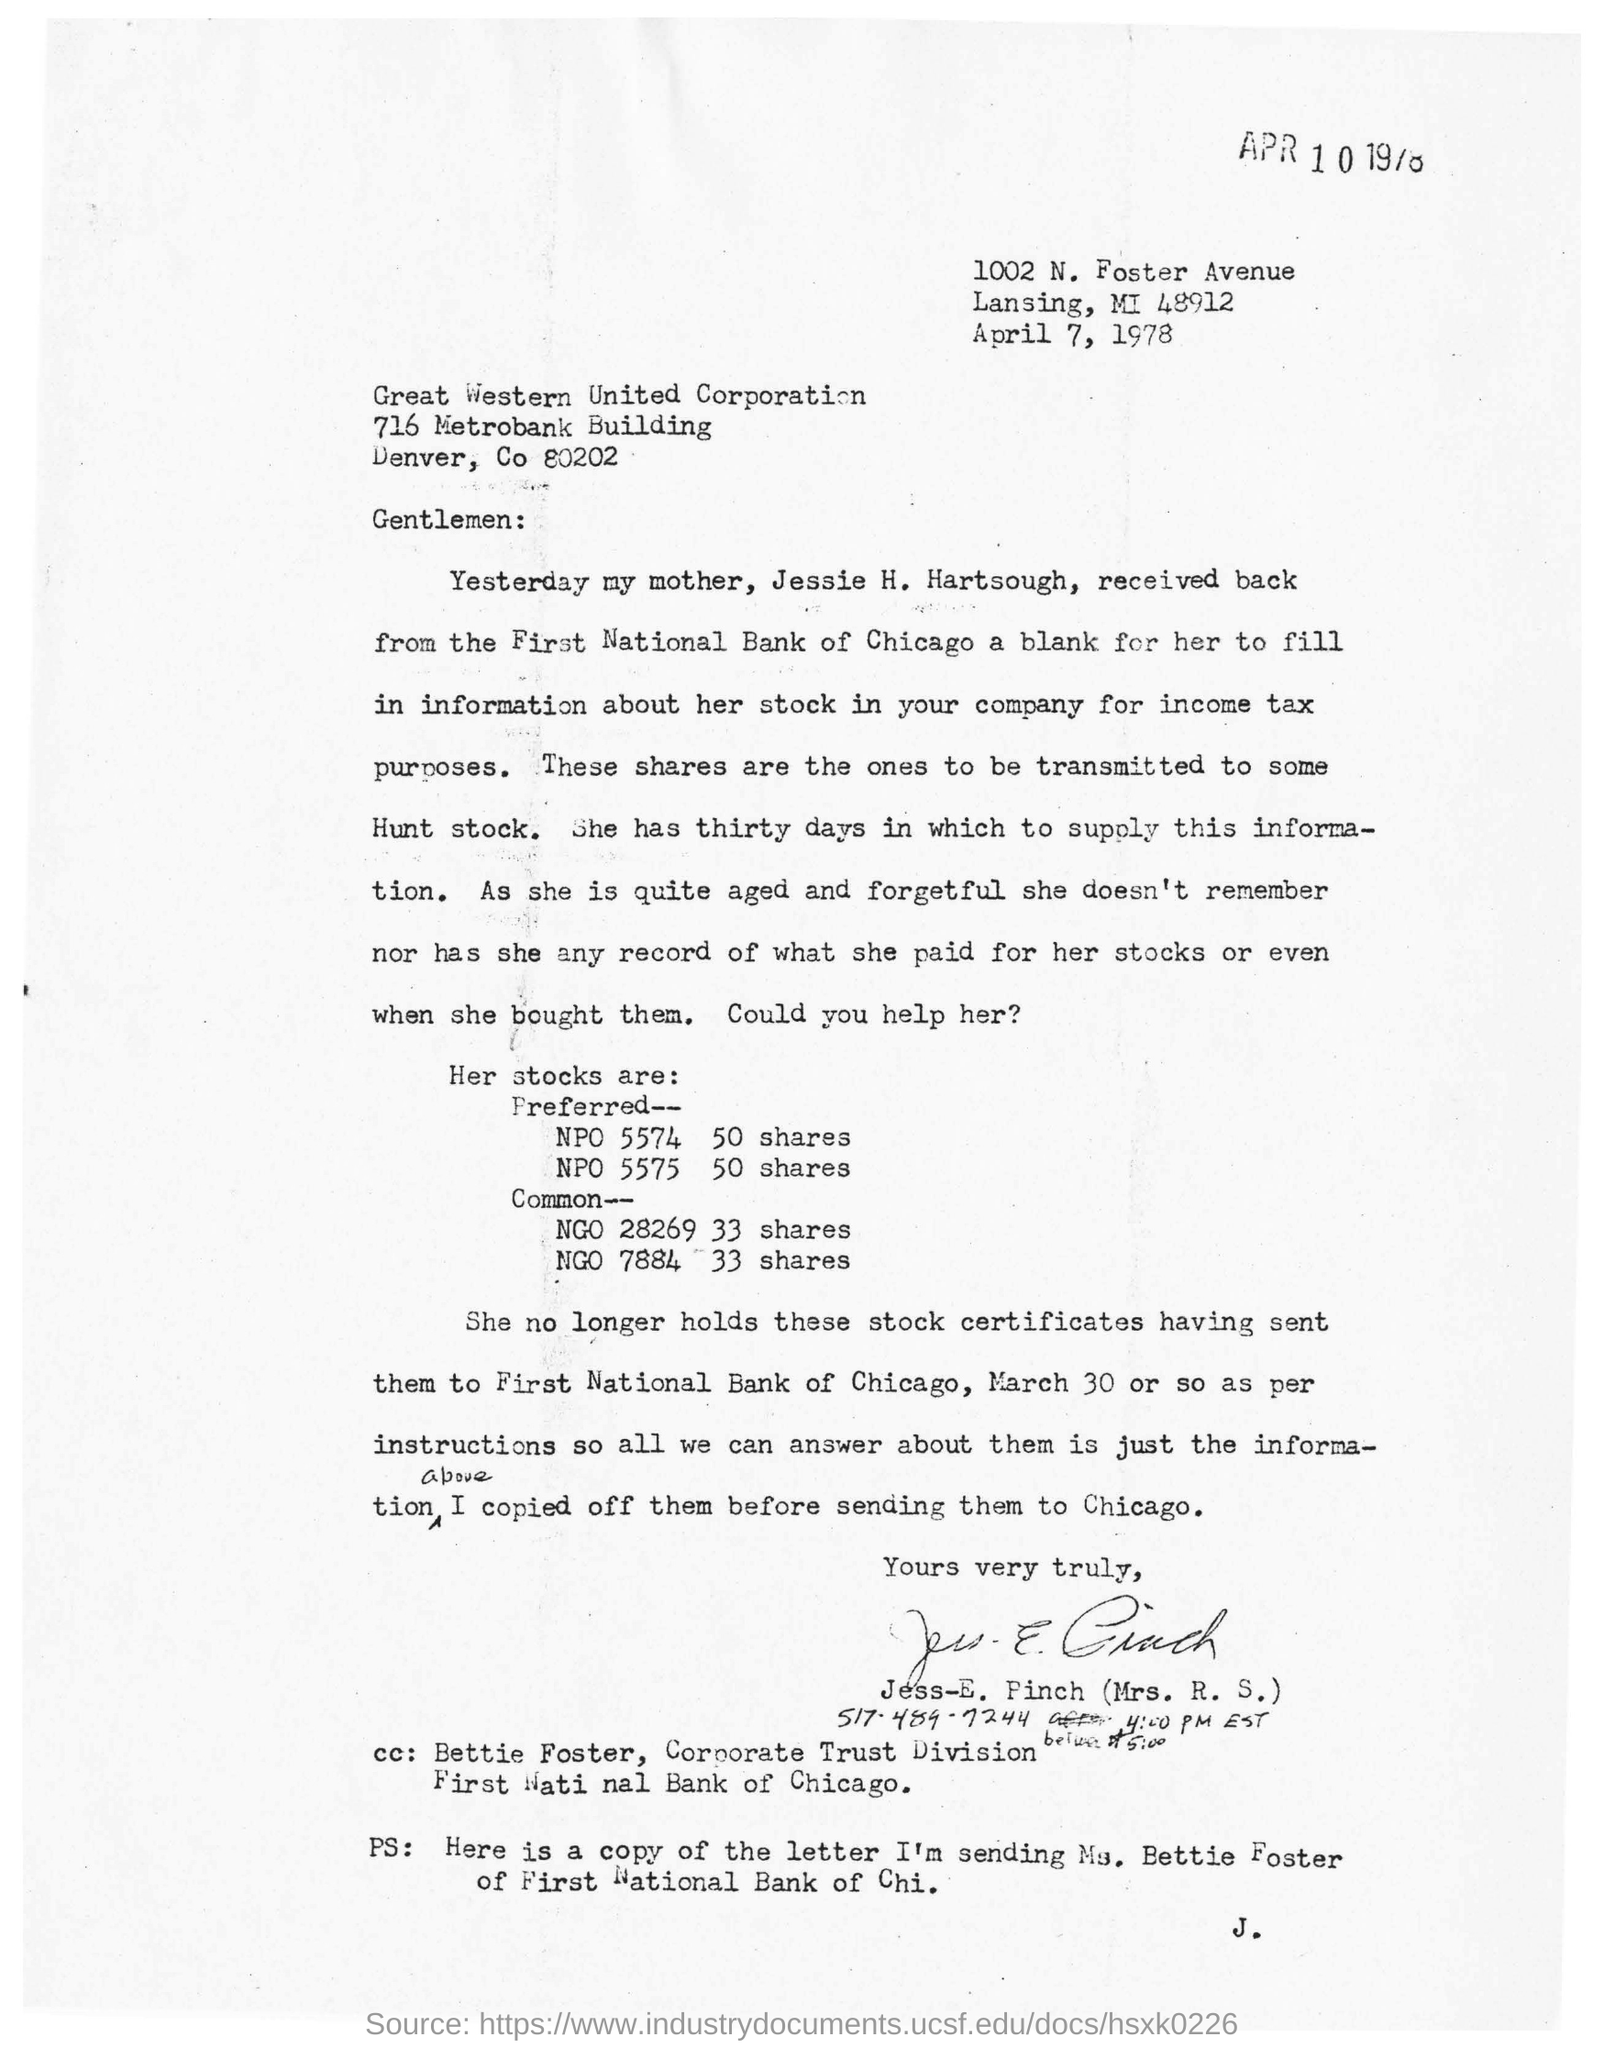When is the letter dated on?
Provide a succinct answer. April 7, 1978. 